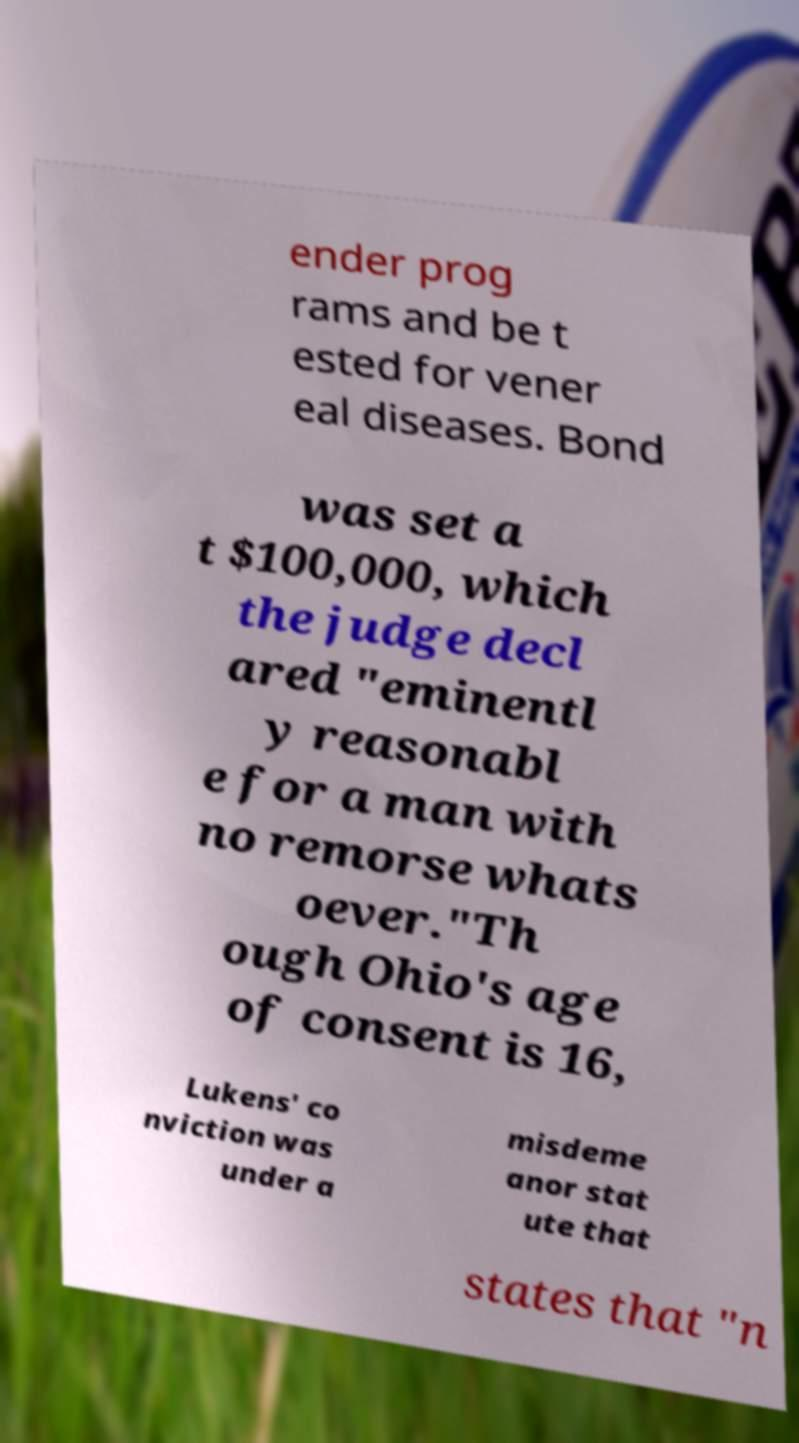Can you read and provide the text displayed in the image?This photo seems to have some interesting text. Can you extract and type it out for me? ender prog rams and be t ested for vener eal diseases. Bond was set a t $100,000, which the judge decl ared "eminentl y reasonabl e for a man with no remorse whats oever."Th ough Ohio's age of consent is 16, Lukens' co nviction was under a misdeme anor stat ute that states that "n 